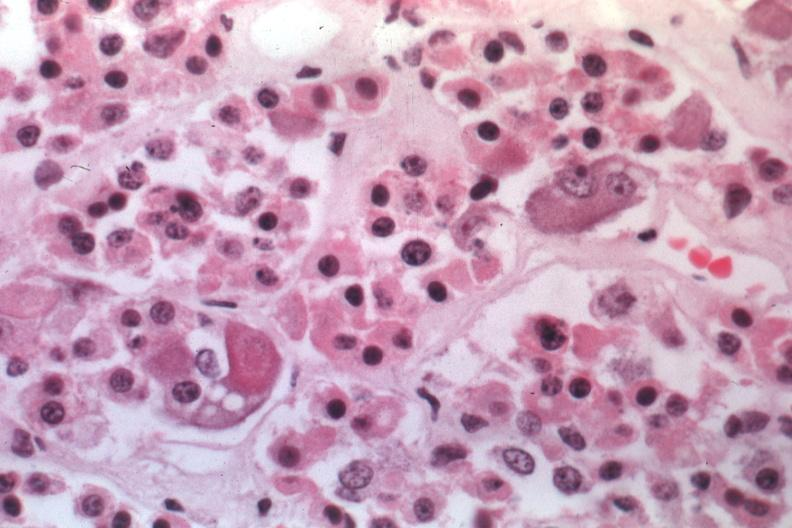where is this part in the figure?
Answer the question using a single word or phrase. Endocrine system 